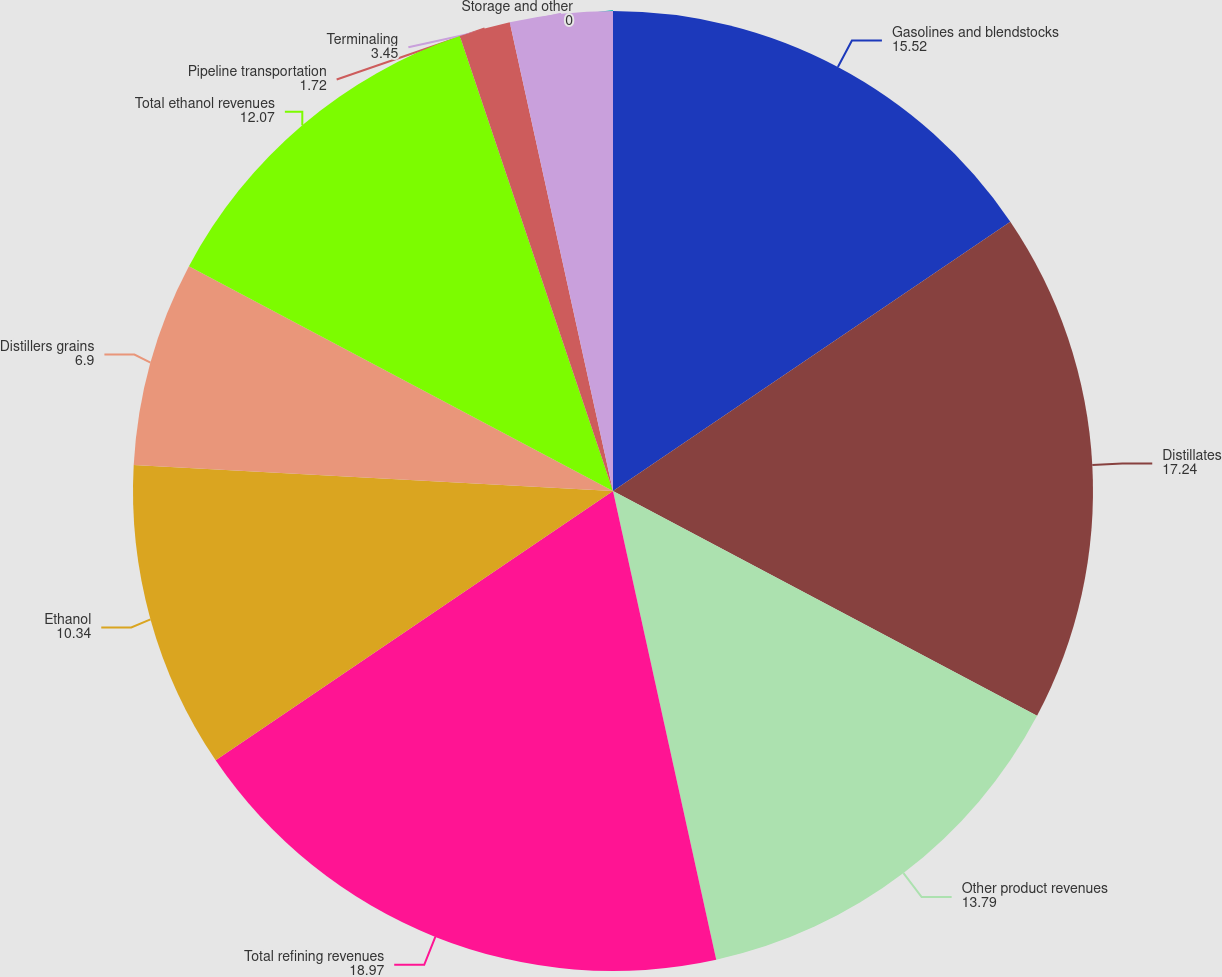Convert chart. <chart><loc_0><loc_0><loc_500><loc_500><pie_chart><fcel>Gasolines and blendstocks<fcel>Distillates<fcel>Other product revenues<fcel>Total refining revenues<fcel>Ethanol<fcel>Distillers grains<fcel>Total ethanol revenues<fcel>Pipeline transportation<fcel>Terminaling<fcel>Storage and other<nl><fcel>15.52%<fcel>17.24%<fcel>13.79%<fcel>18.97%<fcel>10.34%<fcel>6.9%<fcel>12.07%<fcel>1.72%<fcel>3.45%<fcel>0.0%<nl></chart> 